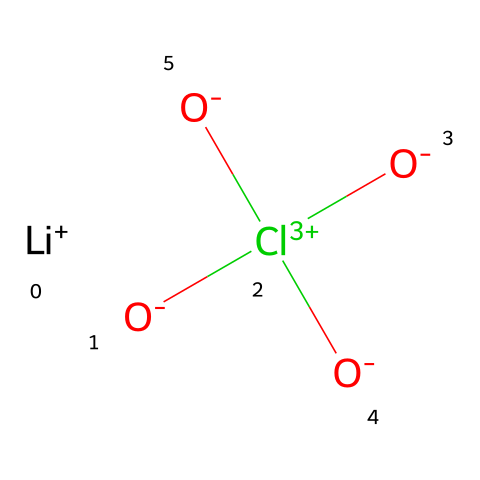How many oxygen atoms are present in lithium perchlorate? By examining the chemical structure represented by the SMILES notation, we can see that there are four oxygen atoms connected to the chlorine atom (Cl). Thus, counting those yields a total of four oxygen atoms.
Answer: four What is the central atom in lithium perchlorate? The structure indicates that chlorine (Cl) is the central atom connected to four oxygen atoms. Therefore, it is clear from the visual arrangement that chlorine is the key central atom in this compound.
Answer: chlorine How does lithium perchlorate behave in water? Given that lithium perchlorate is a soluble salt, it dissociates into lithium ions and perchlorate ions when added to water, indicating it exhibits ionic behavior in aqueous solutions.
Answer: soluble What is the oxidation state of chlorine in lithium perchlorate? In the perchlorate ion (ClO4-), the chlorine is in a high oxidation state, specifically +7, as determined by the bonding and charge distribution among the atoms, based on oxidation state rules.
Answer: +7 Is lithium perchlorate an oxidizer? The presence of the ClO4- group in lithium perchlorate is characteristic of strong oxidizers, as the perchlorate ion can readily release oxygen and support combustion, confirming its classification as an oxidizer.
Answer: yes What type of bond exists between lithium and perchlorate in lithium perchlorate? The bond formed between lithium and the perchlorate ion in this compound is ionic in nature, as lithium, a metal, and perchlorate, a polyatomic anion, combine through electrostatic attraction.
Answer: ionic 